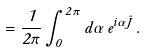<formula> <loc_0><loc_0><loc_500><loc_500>\Pi = \frac { 1 } { 2 \pi } \int _ { 0 } ^ { 2 \pi } d \alpha \, e ^ { i \alpha \hat { J } } \, .</formula> 